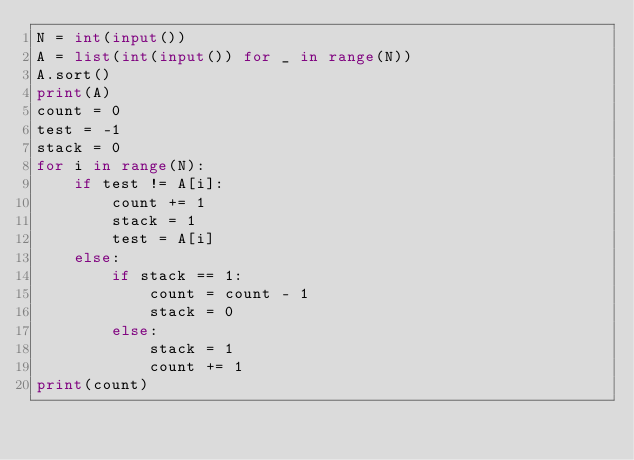<code> <loc_0><loc_0><loc_500><loc_500><_Python_>N = int(input())
A = list(int(input()) for _ in range(N))
A.sort()
print(A)
count = 0
test = -1
stack = 0
for i in range(N):
    if test != A[i]:
        count += 1
        stack = 1
        test = A[i]
    else:
        if stack == 1:
            count = count - 1
            stack = 0
        else:
            stack = 1
            count += 1
print(count)
</code> 